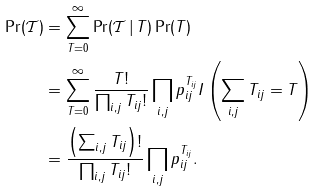Convert formula to latex. <formula><loc_0><loc_0><loc_500><loc_500>\Pr ( \mathcal { T } ) & = \sum _ { T = 0 } ^ { \infty } \Pr ( \mathcal { T } \, | \, T ) \Pr ( T ) \\ & = \sum _ { T = 0 } ^ { \infty } \frac { T ! } { \prod _ { i , j } T _ { i j } ! } \prod _ { i , j } p _ { i j } ^ { T _ { i j } } I \left ( \sum _ { i , j } T _ { i j } = T \right ) \\ & = \frac { \left ( \sum _ { i , j } T _ { i j } \right ) ! } { \prod _ { i , j } T _ { i j } ! } \prod _ { i , j } p _ { i j } ^ { T _ { i j } } .</formula> 